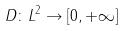Convert formula to latex. <formula><loc_0><loc_0><loc_500><loc_500>D \colon L ^ { 2 } \rightarrow [ 0 , + \infty ]</formula> 